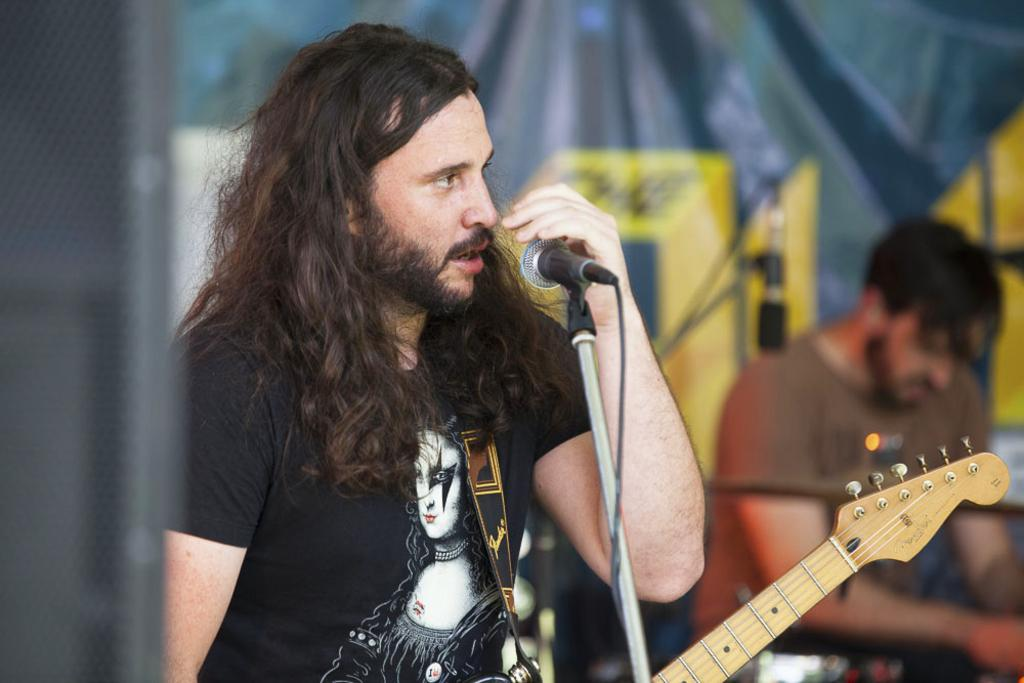What is the man in the foreground of the image doing? The man is standing in front of a mic. Can you describe the setting of the image? There is another man in the background of the image. What color is the balloon being held by the man in the background? There is no balloon present in the image. What type of polish is the coach applying to the man's shoes? There is no coach or mention of polishing shoes in the image. 